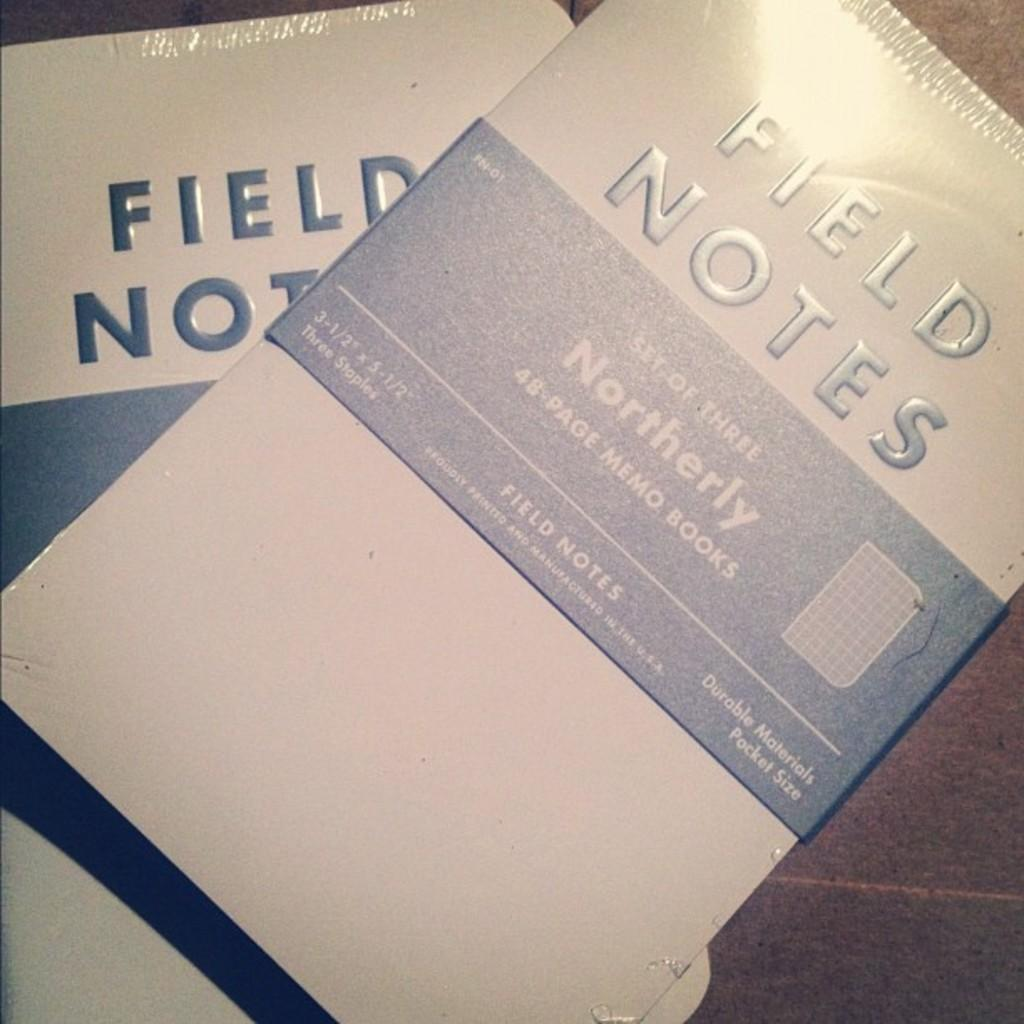<image>
Write a terse but informative summary of the picture. A field notes notebook set contains three books of 48 pages each. 